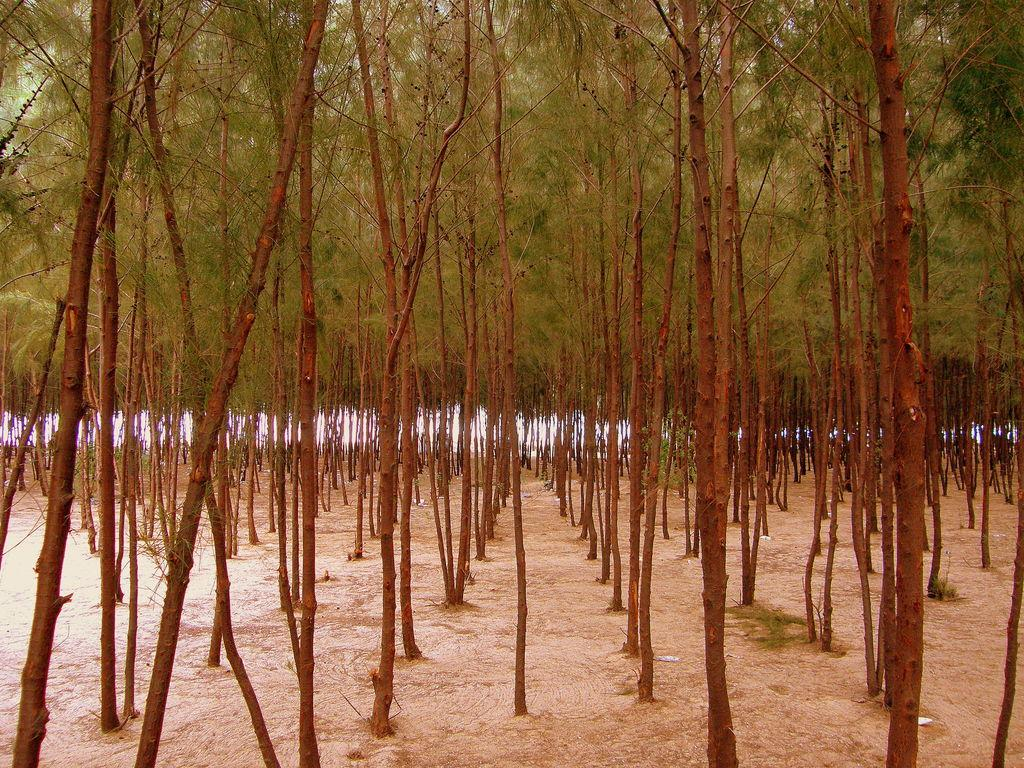What type of vegetation can be seen in the image? There are trees in the image. What is present at the bottom of the image? There is sand at the bottom of the image. What type of yarn is being used to create the dock in the image? There is no dock present in the image, and therefore no yarn is being used to create it. 